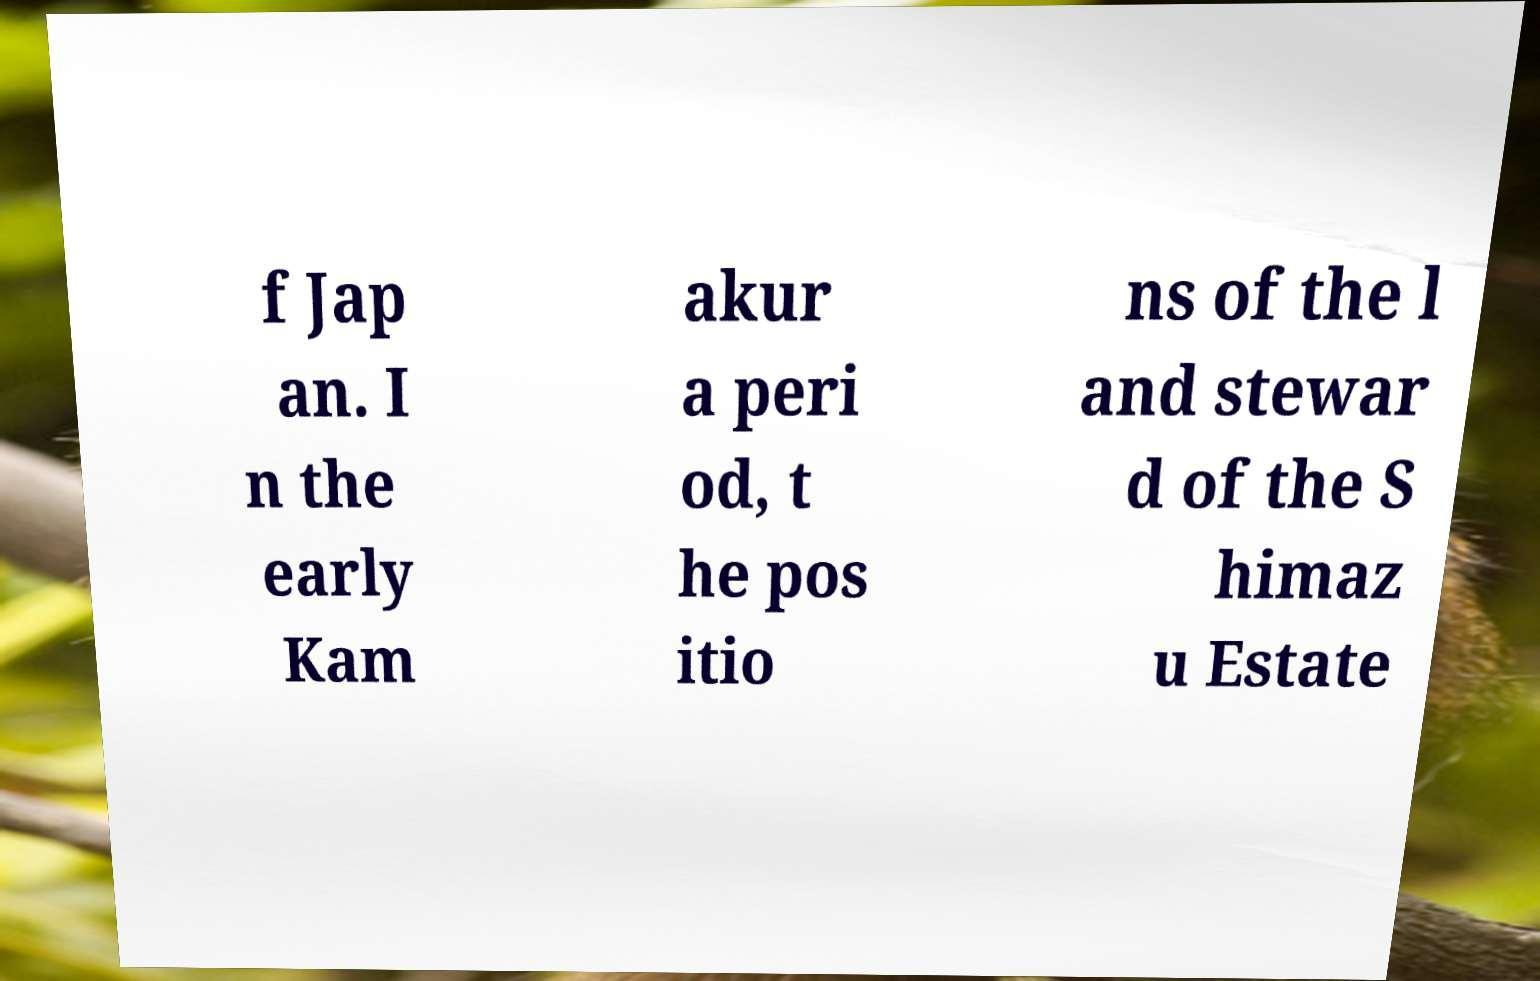Please read and relay the text visible in this image. What does it say? f Jap an. I n the early Kam akur a peri od, t he pos itio ns of the l and stewar d of the S himaz u Estate 